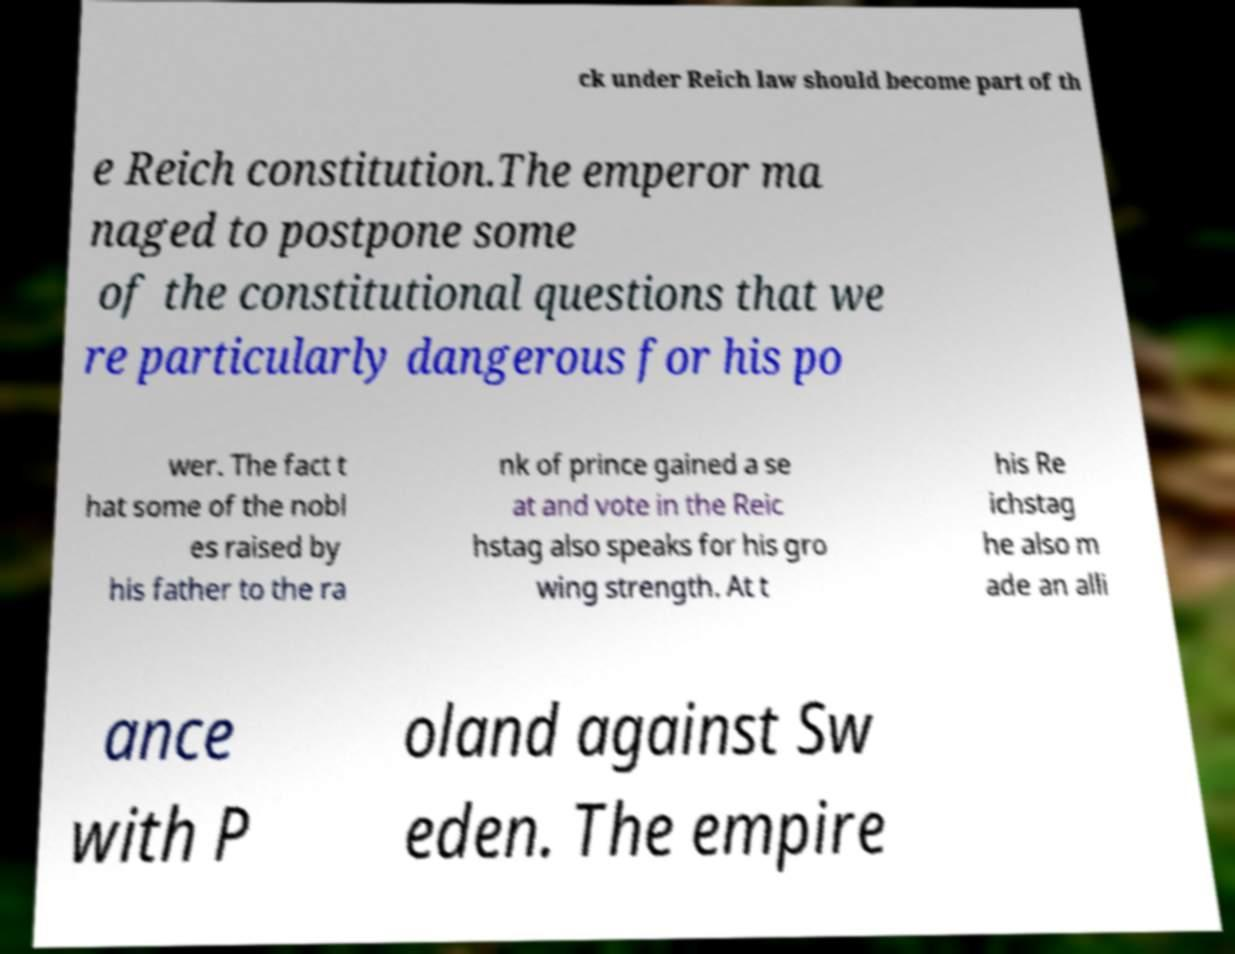What messages or text are displayed in this image? I need them in a readable, typed format. ck under Reich law should become part of th e Reich constitution.The emperor ma naged to postpone some of the constitutional questions that we re particularly dangerous for his po wer. The fact t hat some of the nobl es raised by his father to the ra nk of prince gained a se at and vote in the Reic hstag also speaks for his gro wing strength. At t his Re ichstag he also m ade an alli ance with P oland against Sw eden. The empire 